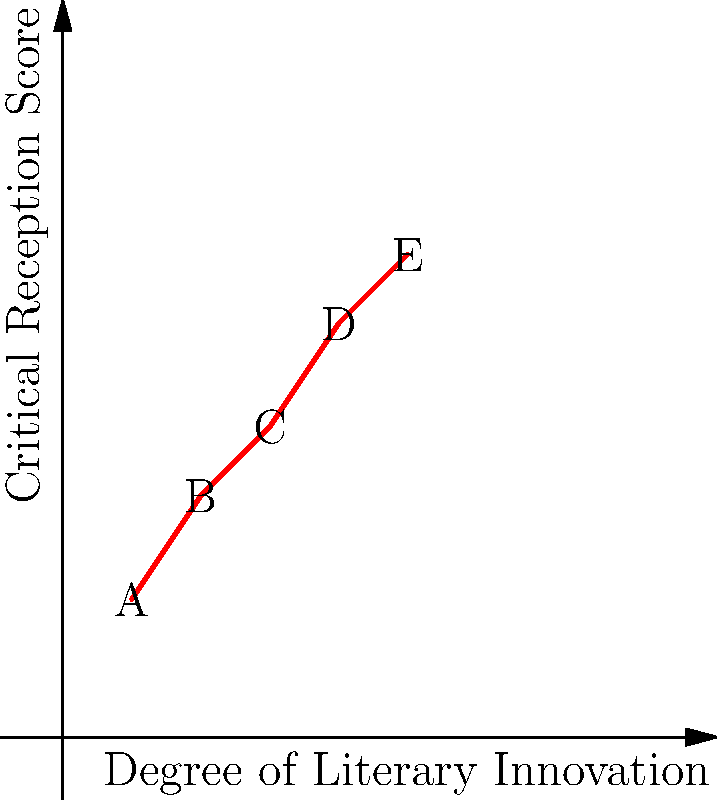The graph represents the correlation between the degree of literary innovation and critical reception scores for five novels (A, B, C, D, E). Which novel demonstrates the highest degree of literary innovation while maintaining a strong critical reception, and what might this suggest about the relationship between rule-breaking and literary success? To answer this question, we need to analyze the graph and interpret its implications:

1. The x-axis represents the degree of literary innovation, increasing from left to right.
2. The y-axis represents the critical reception score, increasing from bottom to top.
3. Each point (A, B, C, D, E) represents a novel.

Analyzing the novels:
A: Low innovation, low reception
B: Slightly higher innovation and reception than A
C: Moderate innovation and reception
D: High innovation, high reception
E: Highest innovation, highest reception

Novel E shows the highest degree of literary innovation (x=5) while also achieving the highest critical reception score (y=7). This suggests a strong positive correlation between innovation and critical success.

The overall trend of the graph shows that as literary innovation increases, critical reception tends to improve. This pattern implies that rule-breaking in literature, when done effectively, can lead to greater critical acclaim.

For a scholar examining the impact of rule-breaking on the literary canon, this graph supports the notion that innovative works that challenge conventional norms are often well-received by critics and may have a higher likelihood of entering the literary canon.

Novel E, being at the extreme end of both axes, represents a work that has successfully pushed boundaries in literature while garnering significant critical approval. This exemplifies how rule-breaking, when executed skillfully, can result in both innovation and critical success.
Answer: Novel E; positive correlation between innovation and critical success 